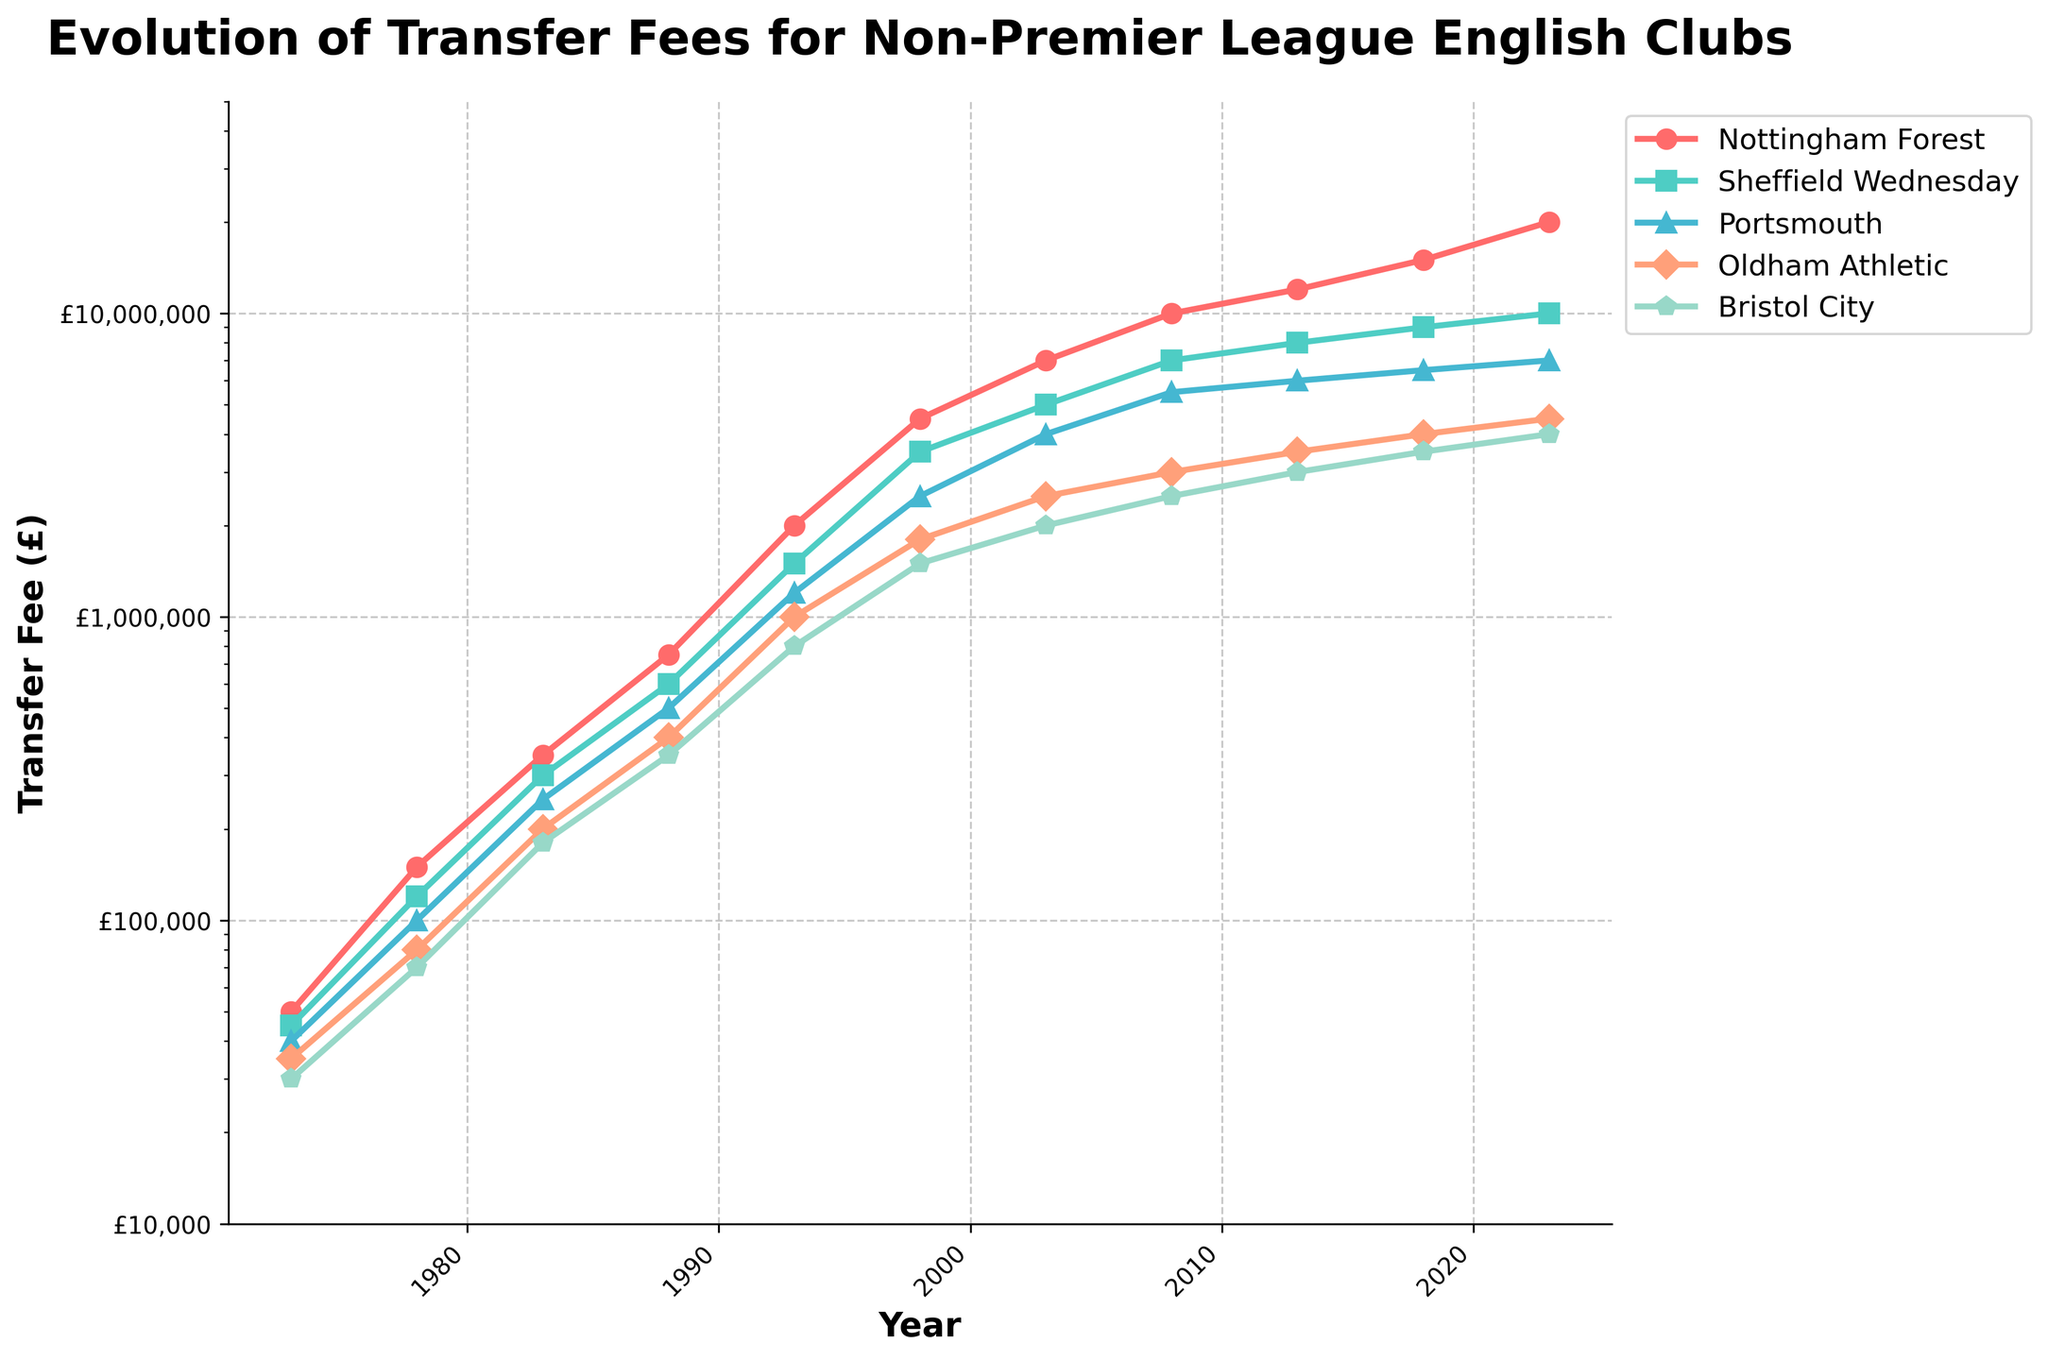How has the transfer fee for Nottingham Forest changed from 1973 to 2023? The transfer fee for Nottingham Forest in 1973 was £50,000, and in 2023 it is £20,000,000. The change in transfer fee is £20,000,000 - £50,000 = £19,950,000.
Answer: Increased by £19,950,000 Which club had the highest transfer fee in 2018? By looking at the plotted lines and their corresponding markers for the year 2018, Nottingham Forest had the highest transfer fee at £15,000,000.
Answer: Nottingham Forest Compare the transfer fees of Sheffield Wednesday and Oldham Athletic in 2003. Which club had a higher fee, and by how much? In 2003, Sheffield Wednesday had a transfer fee of £5,000,000 and Oldham Athletic had £2,500,000. The difference is £5,000,000 - £2,500,000 = £2,500,000.
Answer: Sheffield Wednesday, by £2,500,000 What is the average transfer fee for Bristol City from 1998 to 2023? The fees for Bristol City from 1998 to 2023 are £1,500,000, £2,000,000, £2,500,000, £3,000,000, £3,500,000, and £4,000,000. Summing these values gives £16,500,000, dividing by 6 gives £16,500,000 / 6 = £2,750,000.
Answer: £2,750,000 Which club showed the most significant increase in transfer fees between 1983 and 1988? By comparing the values from 1983 to 1988, Nottingham Forest increased from £350,000 to £750,000 (£400,000), Sheffield Wednesday from £300,000 to £600,000 (£300,000), Portsmouth from £250,000 to £500,000 (£250,000), Oldham Athletic from £200,000 to £400,000 (£200,000), and Bristol City from £180,000 to £350,000 (£170,000). The highest increase was Nottingham Forest with £400,000.
Answer: Nottingham Forest What color represents Sheffield Wednesday on the plot? The color used for Sheffield Wednesday is a distinct turquoise-like shade, represented by a greenish-blue line.
Answer: Greenish-blue How did the transfer fee for Portsmouth evolve from 2003 to 2023? The transfer fees for Portsmouth in 2003 to 2023 are £4,000,000, £5,500,000, £6,000,000, £6,500,000, and £7,000,000, respectively. This shows a steady increase across these years.
Answer: Steadily increased Find the median transfer fee for Oldham Athletic between 1978 and 2018. The transfer fees for Oldham Athletic in these years are £80,000, £200,000, £400,000, £1,000,000, £1,800,000, £2,500,000, and £3,500,000. Arranging these in ascending order gives £80,000, £200,000, £400,000, £1,000,000, £1,800,000, £2,500,000, and £3,500,000. The median value is £1,000,000 (the fourth value).
Answer: £1,000,000 